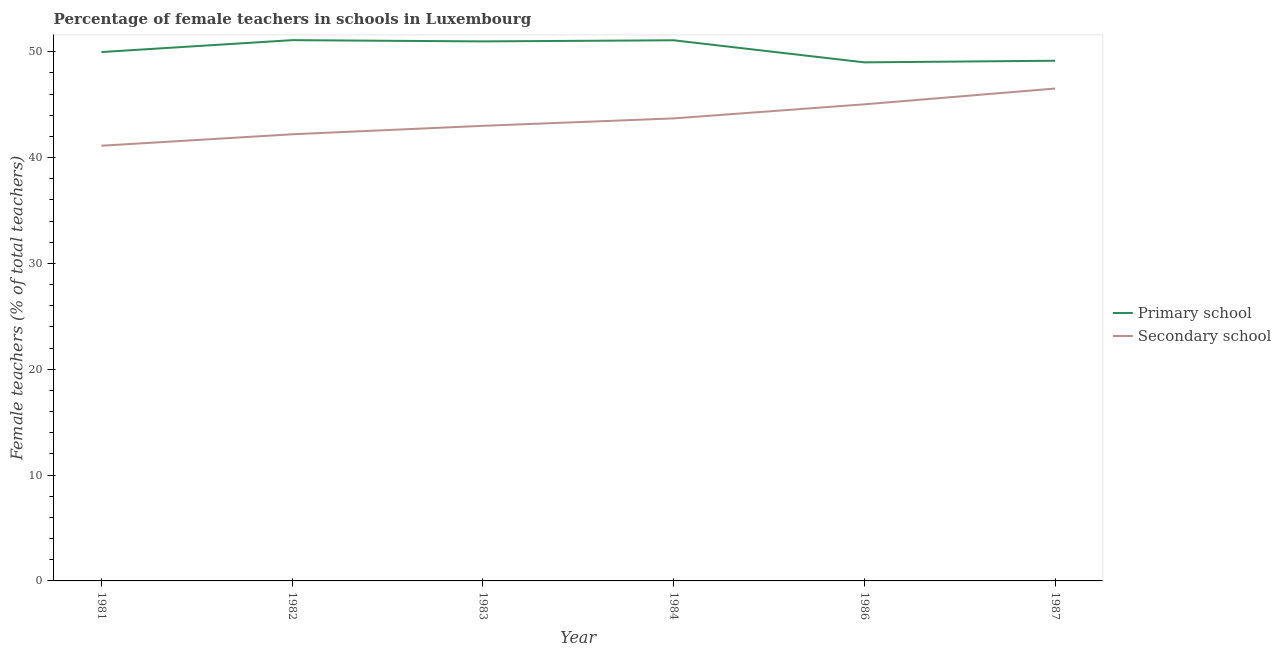Does the line corresponding to percentage of female teachers in primary schools intersect with the line corresponding to percentage of female teachers in secondary schools?
Provide a short and direct response. No. What is the percentage of female teachers in primary schools in 1981?
Keep it short and to the point. 49.97. Across all years, what is the maximum percentage of female teachers in secondary schools?
Provide a succinct answer. 46.52. Across all years, what is the minimum percentage of female teachers in secondary schools?
Offer a very short reply. 41.12. What is the total percentage of female teachers in secondary schools in the graph?
Offer a terse response. 261.58. What is the difference between the percentage of female teachers in primary schools in 1983 and that in 1984?
Give a very brief answer. -0.11. What is the difference between the percentage of female teachers in secondary schools in 1986 and the percentage of female teachers in primary schools in 1982?
Provide a short and direct response. -6.06. What is the average percentage of female teachers in primary schools per year?
Your answer should be compact. 50.21. In the year 1986, what is the difference between the percentage of female teachers in secondary schools and percentage of female teachers in primary schools?
Provide a succinct answer. -3.96. In how many years, is the percentage of female teachers in secondary schools greater than 48 %?
Keep it short and to the point. 0. What is the ratio of the percentage of female teachers in primary schools in 1982 to that in 1987?
Your answer should be very brief. 1.04. Is the percentage of female teachers in secondary schools in 1984 less than that in 1986?
Your answer should be compact. Yes. Is the difference between the percentage of female teachers in secondary schools in 1983 and 1984 greater than the difference between the percentage of female teachers in primary schools in 1983 and 1984?
Your answer should be very brief. No. What is the difference between the highest and the second highest percentage of female teachers in primary schools?
Provide a succinct answer. 0.01. What is the difference between the highest and the lowest percentage of female teachers in secondary schools?
Give a very brief answer. 5.4. In how many years, is the percentage of female teachers in secondary schools greater than the average percentage of female teachers in secondary schools taken over all years?
Offer a very short reply. 3. Is the sum of the percentage of female teachers in secondary schools in 1981 and 1986 greater than the maximum percentage of female teachers in primary schools across all years?
Your response must be concise. Yes. Is the percentage of female teachers in primary schools strictly greater than the percentage of female teachers in secondary schools over the years?
Provide a succinct answer. Yes. Is the percentage of female teachers in secondary schools strictly less than the percentage of female teachers in primary schools over the years?
Provide a succinct answer. Yes. How many lines are there?
Offer a terse response. 2. What is the difference between two consecutive major ticks on the Y-axis?
Offer a terse response. 10. Does the graph contain any zero values?
Give a very brief answer. No. Does the graph contain grids?
Offer a very short reply. No. How many legend labels are there?
Give a very brief answer. 2. How are the legend labels stacked?
Your answer should be very brief. Vertical. What is the title of the graph?
Your answer should be compact. Percentage of female teachers in schools in Luxembourg. What is the label or title of the X-axis?
Your response must be concise. Year. What is the label or title of the Y-axis?
Provide a succinct answer. Female teachers (% of total teachers). What is the Female teachers (% of total teachers) of Primary school in 1981?
Keep it short and to the point. 49.97. What is the Female teachers (% of total teachers) in Secondary school in 1981?
Offer a terse response. 41.12. What is the Female teachers (% of total teachers) of Primary school in 1982?
Provide a short and direct response. 51.1. What is the Female teachers (% of total teachers) in Secondary school in 1982?
Provide a succinct answer. 42.2. What is the Female teachers (% of total teachers) in Primary school in 1983?
Ensure brevity in your answer.  50.98. What is the Female teachers (% of total teachers) in Secondary school in 1983?
Give a very brief answer. 43. What is the Female teachers (% of total teachers) in Primary school in 1984?
Your response must be concise. 51.08. What is the Female teachers (% of total teachers) in Secondary school in 1984?
Give a very brief answer. 43.7. What is the Female teachers (% of total teachers) in Primary school in 1986?
Provide a short and direct response. 49. What is the Female teachers (% of total teachers) in Secondary school in 1986?
Provide a short and direct response. 45.03. What is the Female teachers (% of total teachers) in Primary school in 1987?
Your response must be concise. 49.15. What is the Female teachers (% of total teachers) in Secondary school in 1987?
Keep it short and to the point. 46.52. Across all years, what is the maximum Female teachers (% of total teachers) of Primary school?
Give a very brief answer. 51.1. Across all years, what is the maximum Female teachers (% of total teachers) of Secondary school?
Make the answer very short. 46.52. Across all years, what is the minimum Female teachers (% of total teachers) of Primary school?
Make the answer very short. 49. Across all years, what is the minimum Female teachers (% of total teachers) in Secondary school?
Make the answer very short. 41.12. What is the total Female teachers (% of total teachers) in Primary school in the graph?
Offer a terse response. 301.28. What is the total Female teachers (% of total teachers) in Secondary school in the graph?
Ensure brevity in your answer.  261.58. What is the difference between the Female teachers (% of total teachers) in Primary school in 1981 and that in 1982?
Keep it short and to the point. -1.12. What is the difference between the Female teachers (% of total teachers) in Secondary school in 1981 and that in 1982?
Make the answer very short. -1.08. What is the difference between the Female teachers (% of total teachers) in Primary school in 1981 and that in 1983?
Offer a very short reply. -1.01. What is the difference between the Female teachers (% of total teachers) in Secondary school in 1981 and that in 1983?
Provide a short and direct response. -1.88. What is the difference between the Female teachers (% of total teachers) of Primary school in 1981 and that in 1984?
Your answer should be very brief. -1.11. What is the difference between the Female teachers (% of total teachers) of Secondary school in 1981 and that in 1984?
Make the answer very short. -2.58. What is the difference between the Female teachers (% of total teachers) of Primary school in 1981 and that in 1986?
Give a very brief answer. 0.97. What is the difference between the Female teachers (% of total teachers) of Secondary school in 1981 and that in 1986?
Offer a very short reply. -3.91. What is the difference between the Female teachers (% of total teachers) of Primary school in 1981 and that in 1987?
Your response must be concise. 0.82. What is the difference between the Female teachers (% of total teachers) of Secondary school in 1981 and that in 1987?
Your answer should be compact. -5.4. What is the difference between the Female teachers (% of total teachers) of Primary school in 1982 and that in 1983?
Offer a terse response. 0.12. What is the difference between the Female teachers (% of total teachers) of Secondary school in 1982 and that in 1983?
Give a very brief answer. -0.8. What is the difference between the Female teachers (% of total teachers) in Primary school in 1982 and that in 1984?
Your response must be concise. 0.01. What is the difference between the Female teachers (% of total teachers) of Secondary school in 1982 and that in 1984?
Keep it short and to the point. -1.5. What is the difference between the Female teachers (% of total teachers) of Primary school in 1982 and that in 1986?
Your answer should be very brief. 2.1. What is the difference between the Female teachers (% of total teachers) of Secondary school in 1982 and that in 1986?
Ensure brevity in your answer.  -2.83. What is the difference between the Female teachers (% of total teachers) in Primary school in 1982 and that in 1987?
Offer a very short reply. 1.94. What is the difference between the Female teachers (% of total teachers) of Secondary school in 1982 and that in 1987?
Keep it short and to the point. -4.32. What is the difference between the Female teachers (% of total teachers) in Primary school in 1983 and that in 1984?
Offer a very short reply. -0.11. What is the difference between the Female teachers (% of total teachers) of Secondary school in 1983 and that in 1984?
Provide a succinct answer. -0.7. What is the difference between the Female teachers (% of total teachers) of Primary school in 1983 and that in 1986?
Offer a terse response. 1.98. What is the difference between the Female teachers (% of total teachers) of Secondary school in 1983 and that in 1986?
Give a very brief answer. -2.03. What is the difference between the Female teachers (% of total teachers) in Primary school in 1983 and that in 1987?
Your answer should be compact. 1.83. What is the difference between the Female teachers (% of total teachers) in Secondary school in 1983 and that in 1987?
Ensure brevity in your answer.  -3.52. What is the difference between the Female teachers (% of total teachers) in Primary school in 1984 and that in 1986?
Give a very brief answer. 2.09. What is the difference between the Female teachers (% of total teachers) in Secondary school in 1984 and that in 1986?
Provide a short and direct response. -1.33. What is the difference between the Female teachers (% of total teachers) of Primary school in 1984 and that in 1987?
Your response must be concise. 1.93. What is the difference between the Female teachers (% of total teachers) in Secondary school in 1984 and that in 1987?
Ensure brevity in your answer.  -2.82. What is the difference between the Female teachers (% of total teachers) in Primary school in 1986 and that in 1987?
Keep it short and to the point. -0.15. What is the difference between the Female teachers (% of total teachers) in Secondary school in 1986 and that in 1987?
Your response must be concise. -1.49. What is the difference between the Female teachers (% of total teachers) of Primary school in 1981 and the Female teachers (% of total teachers) of Secondary school in 1982?
Offer a very short reply. 7.77. What is the difference between the Female teachers (% of total teachers) of Primary school in 1981 and the Female teachers (% of total teachers) of Secondary school in 1983?
Offer a very short reply. 6.97. What is the difference between the Female teachers (% of total teachers) of Primary school in 1981 and the Female teachers (% of total teachers) of Secondary school in 1984?
Ensure brevity in your answer.  6.27. What is the difference between the Female teachers (% of total teachers) of Primary school in 1981 and the Female teachers (% of total teachers) of Secondary school in 1986?
Keep it short and to the point. 4.94. What is the difference between the Female teachers (% of total teachers) in Primary school in 1981 and the Female teachers (% of total teachers) in Secondary school in 1987?
Your answer should be very brief. 3.45. What is the difference between the Female teachers (% of total teachers) of Primary school in 1982 and the Female teachers (% of total teachers) of Secondary school in 1983?
Offer a terse response. 8.09. What is the difference between the Female teachers (% of total teachers) in Primary school in 1982 and the Female teachers (% of total teachers) in Secondary school in 1984?
Provide a short and direct response. 7.39. What is the difference between the Female teachers (% of total teachers) in Primary school in 1982 and the Female teachers (% of total teachers) in Secondary school in 1986?
Offer a very short reply. 6.06. What is the difference between the Female teachers (% of total teachers) in Primary school in 1982 and the Female teachers (% of total teachers) in Secondary school in 1987?
Give a very brief answer. 4.57. What is the difference between the Female teachers (% of total teachers) in Primary school in 1983 and the Female teachers (% of total teachers) in Secondary school in 1984?
Offer a very short reply. 7.28. What is the difference between the Female teachers (% of total teachers) in Primary school in 1983 and the Female teachers (% of total teachers) in Secondary school in 1986?
Ensure brevity in your answer.  5.95. What is the difference between the Female teachers (% of total teachers) of Primary school in 1983 and the Female teachers (% of total teachers) of Secondary school in 1987?
Ensure brevity in your answer.  4.46. What is the difference between the Female teachers (% of total teachers) in Primary school in 1984 and the Female teachers (% of total teachers) in Secondary school in 1986?
Offer a terse response. 6.05. What is the difference between the Female teachers (% of total teachers) in Primary school in 1984 and the Female teachers (% of total teachers) in Secondary school in 1987?
Give a very brief answer. 4.56. What is the difference between the Female teachers (% of total teachers) in Primary school in 1986 and the Female teachers (% of total teachers) in Secondary school in 1987?
Your answer should be compact. 2.47. What is the average Female teachers (% of total teachers) in Primary school per year?
Ensure brevity in your answer.  50.21. What is the average Female teachers (% of total teachers) in Secondary school per year?
Keep it short and to the point. 43.6. In the year 1981, what is the difference between the Female teachers (% of total teachers) of Primary school and Female teachers (% of total teachers) of Secondary school?
Offer a very short reply. 8.85. In the year 1982, what is the difference between the Female teachers (% of total teachers) in Primary school and Female teachers (% of total teachers) in Secondary school?
Provide a short and direct response. 8.89. In the year 1983, what is the difference between the Female teachers (% of total teachers) of Primary school and Female teachers (% of total teachers) of Secondary school?
Your answer should be very brief. 7.98. In the year 1984, what is the difference between the Female teachers (% of total teachers) in Primary school and Female teachers (% of total teachers) in Secondary school?
Make the answer very short. 7.38. In the year 1986, what is the difference between the Female teachers (% of total teachers) in Primary school and Female teachers (% of total teachers) in Secondary school?
Your response must be concise. 3.96. In the year 1987, what is the difference between the Female teachers (% of total teachers) of Primary school and Female teachers (% of total teachers) of Secondary school?
Ensure brevity in your answer.  2.63. What is the ratio of the Female teachers (% of total teachers) of Primary school in 1981 to that in 1982?
Keep it short and to the point. 0.98. What is the ratio of the Female teachers (% of total teachers) in Secondary school in 1981 to that in 1982?
Your response must be concise. 0.97. What is the ratio of the Female teachers (% of total teachers) in Primary school in 1981 to that in 1983?
Offer a terse response. 0.98. What is the ratio of the Female teachers (% of total teachers) in Secondary school in 1981 to that in 1983?
Your answer should be very brief. 0.96. What is the ratio of the Female teachers (% of total teachers) of Primary school in 1981 to that in 1984?
Offer a very short reply. 0.98. What is the ratio of the Female teachers (% of total teachers) of Secondary school in 1981 to that in 1984?
Provide a succinct answer. 0.94. What is the ratio of the Female teachers (% of total teachers) of Primary school in 1981 to that in 1986?
Ensure brevity in your answer.  1.02. What is the ratio of the Female teachers (% of total teachers) of Secondary school in 1981 to that in 1986?
Your answer should be very brief. 0.91. What is the ratio of the Female teachers (% of total teachers) of Primary school in 1981 to that in 1987?
Your response must be concise. 1.02. What is the ratio of the Female teachers (% of total teachers) of Secondary school in 1981 to that in 1987?
Ensure brevity in your answer.  0.88. What is the ratio of the Female teachers (% of total teachers) of Primary school in 1982 to that in 1983?
Offer a terse response. 1. What is the ratio of the Female teachers (% of total teachers) of Secondary school in 1982 to that in 1983?
Provide a short and direct response. 0.98. What is the ratio of the Female teachers (% of total teachers) in Secondary school in 1982 to that in 1984?
Provide a succinct answer. 0.97. What is the ratio of the Female teachers (% of total teachers) of Primary school in 1982 to that in 1986?
Ensure brevity in your answer.  1.04. What is the ratio of the Female teachers (% of total teachers) of Secondary school in 1982 to that in 1986?
Provide a succinct answer. 0.94. What is the ratio of the Female teachers (% of total teachers) of Primary school in 1982 to that in 1987?
Offer a very short reply. 1.04. What is the ratio of the Female teachers (% of total teachers) in Secondary school in 1982 to that in 1987?
Offer a very short reply. 0.91. What is the ratio of the Female teachers (% of total teachers) in Secondary school in 1983 to that in 1984?
Your response must be concise. 0.98. What is the ratio of the Female teachers (% of total teachers) of Primary school in 1983 to that in 1986?
Your answer should be very brief. 1.04. What is the ratio of the Female teachers (% of total teachers) of Secondary school in 1983 to that in 1986?
Your response must be concise. 0.95. What is the ratio of the Female teachers (% of total teachers) in Primary school in 1983 to that in 1987?
Provide a succinct answer. 1.04. What is the ratio of the Female teachers (% of total teachers) of Secondary school in 1983 to that in 1987?
Provide a short and direct response. 0.92. What is the ratio of the Female teachers (% of total teachers) in Primary school in 1984 to that in 1986?
Provide a succinct answer. 1.04. What is the ratio of the Female teachers (% of total teachers) in Secondary school in 1984 to that in 1986?
Make the answer very short. 0.97. What is the ratio of the Female teachers (% of total teachers) in Primary school in 1984 to that in 1987?
Keep it short and to the point. 1.04. What is the ratio of the Female teachers (% of total teachers) of Secondary school in 1984 to that in 1987?
Your answer should be compact. 0.94. What is the difference between the highest and the second highest Female teachers (% of total teachers) of Primary school?
Provide a succinct answer. 0.01. What is the difference between the highest and the second highest Female teachers (% of total teachers) in Secondary school?
Give a very brief answer. 1.49. What is the difference between the highest and the lowest Female teachers (% of total teachers) of Primary school?
Give a very brief answer. 2.1. What is the difference between the highest and the lowest Female teachers (% of total teachers) of Secondary school?
Your answer should be compact. 5.4. 